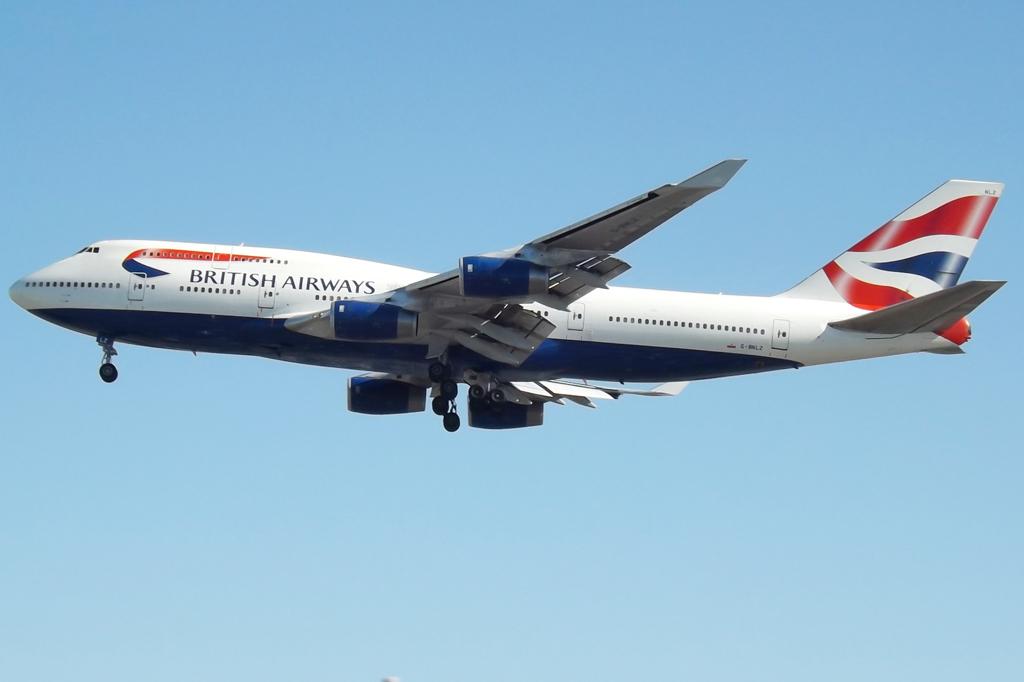What company owns this airline?
Your answer should be very brief. British airways. 